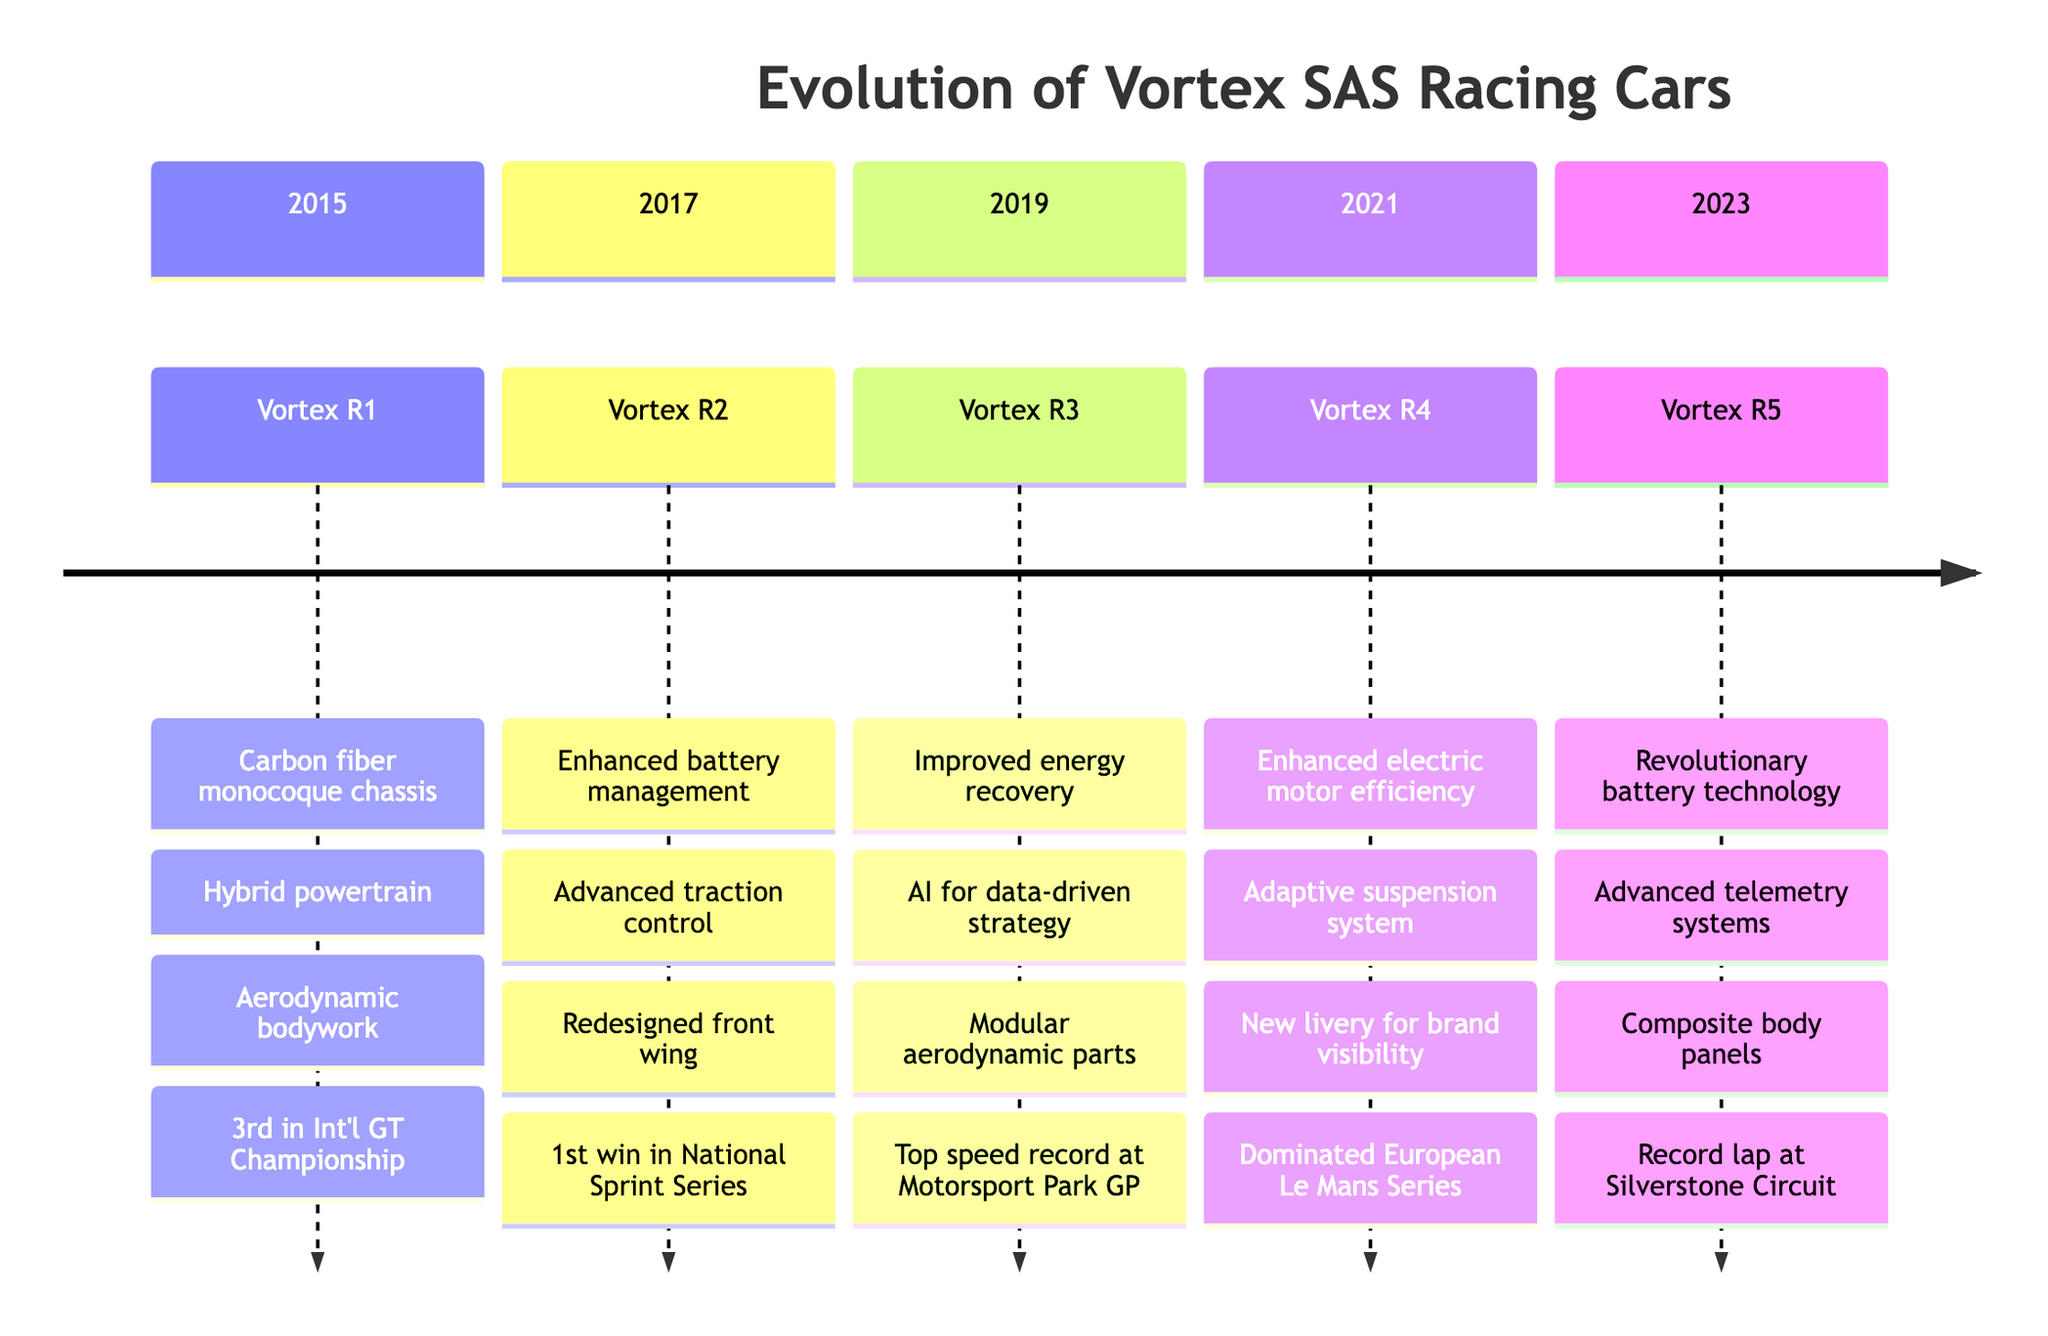What model was introduced in 2015? The diagram shows the timeline starting from 2015, under that section, it lists the model introduced as Vortex R1.
Answer: Vortex R1 Which year saw the first win in the National Sprint Series? Looking at the timeline for 2017, it states that the Vortex R2 achieved the first win in the National Sprint Series.
Answer: 2017 List one design enhancement of the Vortex R4. On the timeline under the 2021 section, it highlights "New livery for better brand visibility" as one of the design enhancements for Vortex R4.
Answer: New livery for better brand visibility How many notable achievements does the Vortex R5 have listed? In the 2023 section of the timeline, Vortex R5 mentions one notable achievement: "Record-breaking lap time at Silverstone Circuit", indicating there is one listed for this model.
Answer: 1 Which Vortex model had an advanced telemetry system? The timeline indicates that in 2023, the Vortex R5 was the model that integrated advanced telemetry systems.
Answer: Vortex R5 What technological advancement was introduced with the Vortex R3? The timeline for 2019 shows two advancements; one of them is "Improved energy recovery system," indicating it was an advancement for Vortex R3.
Answer: Improved energy recovery system What notable achievement is associated with the Vortex R1? The timeline details that Vortex R1 achieved "Third place in International GT Championship" as a notable achievement in 2015.
Answer: Third place in International GT Championship Which model features an adaptive suspension system? The timeline for 2021 indicates that the technological advancement for Vortex R4 includes an "Adaptive suspension system."
Answer: Vortex R4 In which year did Vortex R3 set the top speed record? According to the timeline for 2019, it lists that Vortex R3 set the top speed record at Motorsport Park GP in that year.
Answer: 2019 